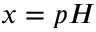Convert formula to latex. <formula><loc_0><loc_0><loc_500><loc_500>x = p H</formula> 